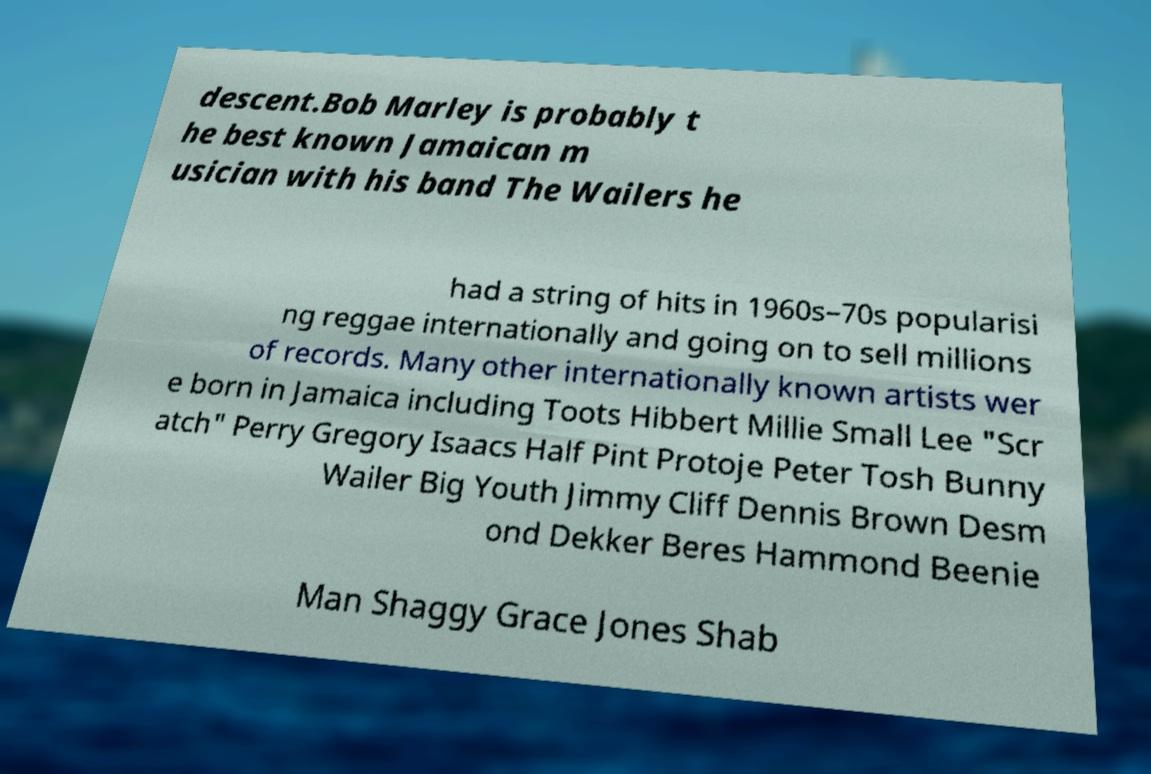Could you extract and type out the text from this image? descent.Bob Marley is probably t he best known Jamaican m usician with his band The Wailers he had a string of hits in 1960s–70s popularisi ng reggae internationally and going on to sell millions of records. Many other internationally known artists wer e born in Jamaica including Toots Hibbert Millie Small Lee "Scr atch" Perry Gregory Isaacs Half Pint Protoje Peter Tosh Bunny Wailer Big Youth Jimmy Cliff Dennis Brown Desm ond Dekker Beres Hammond Beenie Man Shaggy Grace Jones Shab 